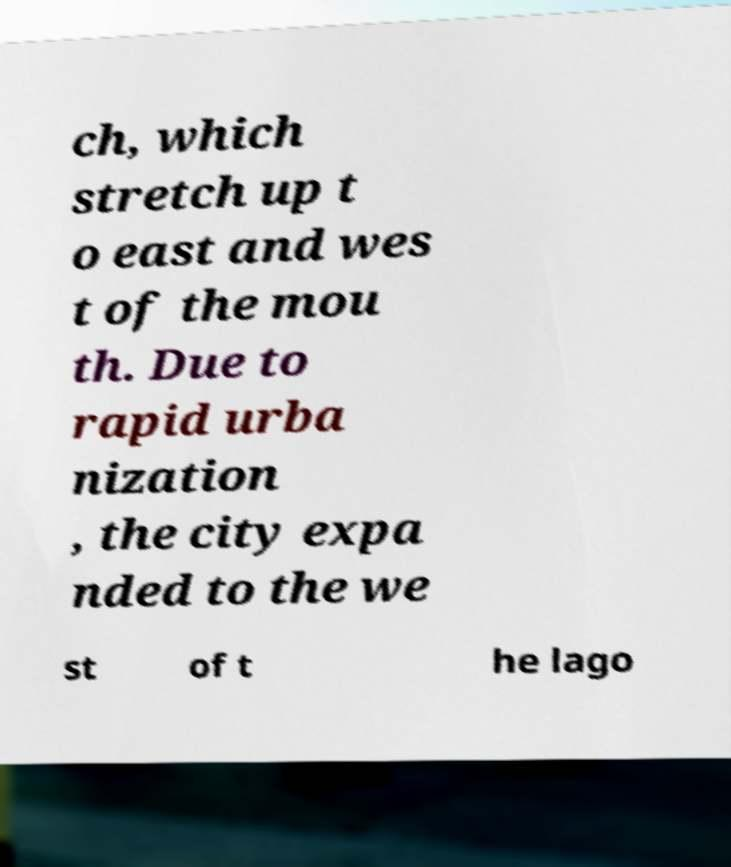What messages or text are displayed in this image? I need them in a readable, typed format. ch, which stretch up t o east and wes t of the mou th. Due to rapid urba nization , the city expa nded to the we st of t he lago 